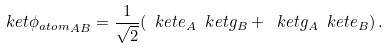Convert formula to latex. <formula><loc_0><loc_0><loc_500><loc_500>\ k e t { { \phi } _ { a t o m } } _ { A B } = \frac { 1 } { \sqrt { 2 } } ( \ k e t { e } _ { A } \ k e t { g } _ { B } + \ k e t { g } _ { A } \ k e t { e } _ { B } ) \, .</formula> 